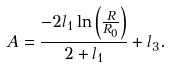<formula> <loc_0><loc_0><loc_500><loc_500>A = \frac { - 2 l _ { 1 } \ln \left ( \frac { R } { R _ { 0 } } \right ) } { 2 + l _ { 1 } } + l _ { 3 } .</formula> 